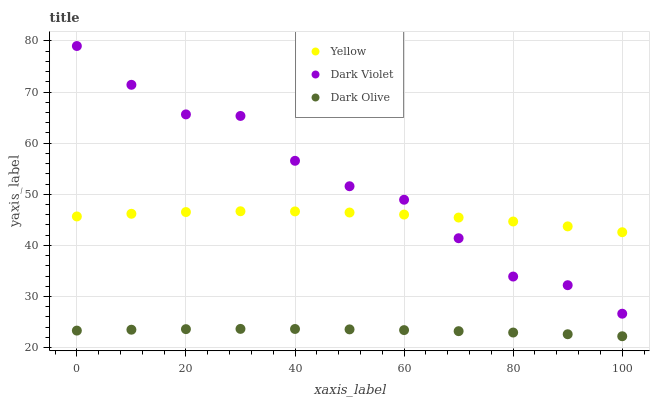Does Dark Olive have the minimum area under the curve?
Answer yes or no. Yes. Does Dark Violet have the maximum area under the curve?
Answer yes or no. Yes. Does Yellow have the minimum area under the curve?
Answer yes or no. No. Does Yellow have the maximum area under the curve?
Answer yes or no. No. Is Dark Olive the smoothest?
Answer yes or no. Yes. Is Dark Violet the roughest?
Answer yes or no. Yes. Is Yellow the smoothest?
Answer yes or no. No. Is Yellow the roughest?
Answer yes or no. No. Does Dark Olive have the lowest value?
Answer yes or no. Yes. Does Dark Violet have the lowest value?
Answer yes or no. No. Does Dark Violet have the highest value?
Answer yes or no. Yes. Does Yellow have the highest value?
Answer yes or no. No. Is Dark Olive less than Yellow?
Answer yes or no. Yes. Is Dark Violet greater than Dark Olive?
Answer yes or no. Yes. Does Dark Violet intersect Yellow?
Answer yes or no. Yes. Is Dark Violet less than Yellow?
Answer yes or no. No. Is Dark Violet greater than Yellow?
Answer yes or no. No. Does Dark Olive intersect Yellow?
Answer yes or no. No. 